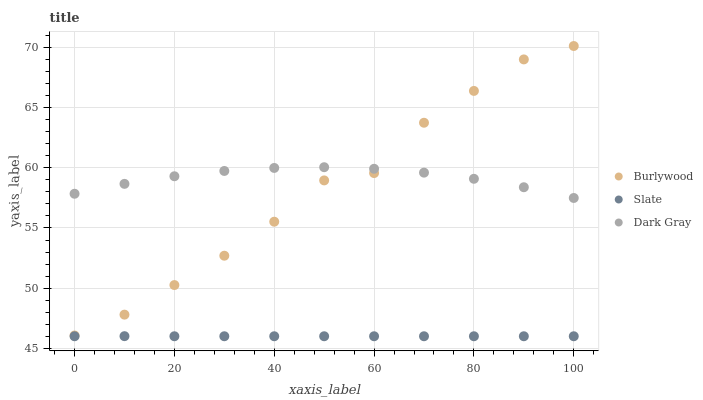Does Slate have the minimum area under the curve?
Answer yes or no. Yes. Does Dark Gray have the maximum area under the curve?
Answer yes or no. Yes. Does Dark Gray have the minimum area under the curve?
Answer yes or no. No. Does Slate have the maximum area under the curve?
Answer yes or no. No. Is Slate the smoothest?
Answer yes or no. Yes. Is Burlywood the roughest?
Answer yes or no. Yes. Is Dark Gray the smoothest?
Answer yes or no. No. Is Dark Gray the roughest?
Answer yes or no. No. Does Slate have the lowest value?
Answer yes or no. Yes. Does Dark Gray have the lowest value?
Answer yes or no. No. Does Burlywood have the highest value?
Answer yes or no. Yes. Does Dark Gray have the highest value?
Answer yes or no. No. Is Slate less than Dark Gray?
Answer yes or no. Yes. Is Dark Gray greater than Slate?
Answer yes or no. Yes. Does Dark Gray intersect Burlywood?
Answer yes or no. Yes. Is Dark Gray less than Burlywood?
Answer yes or no. No. Is Dark Gray greater than Burlywood?
Answer yes or no. No. Does Slate intersect Dark Gray?
Answer yes or no. No. 